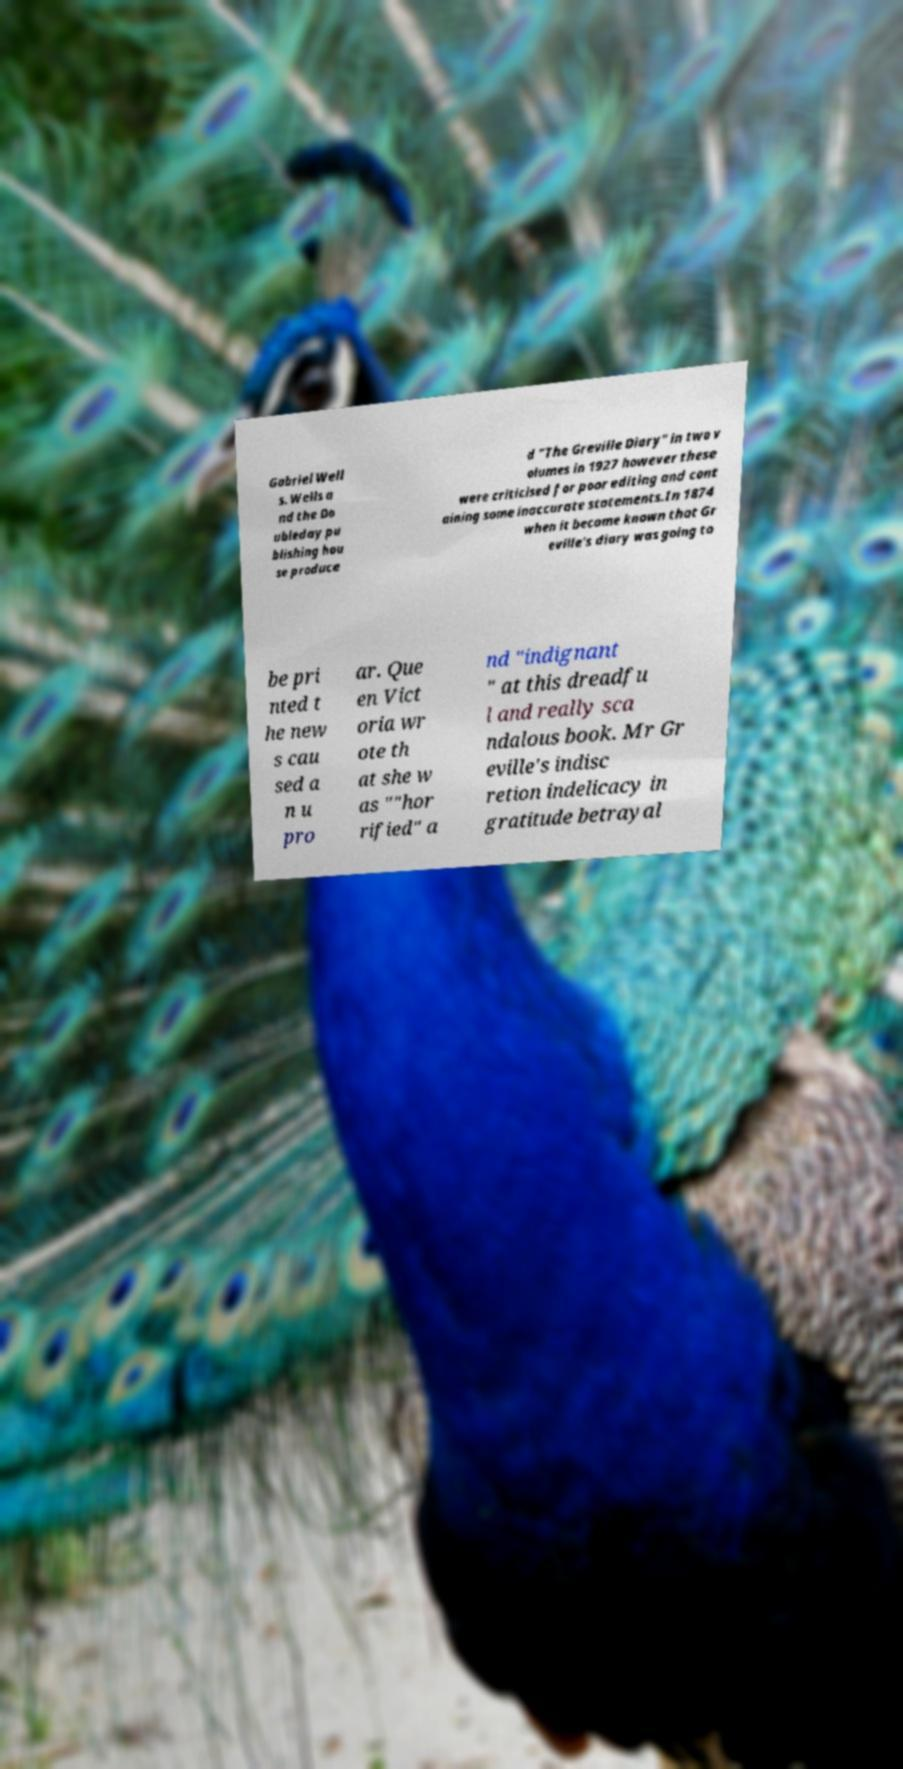Could you assist in decoding the text presented in this image and type it out clearly? Gabriel Well s. Wells a nd the Do ubleday pu blishing hou se produce d "The Greville Diary" in two v olumes in 1927 however these were criticised for poor editing and cont aining some inaccurate statements.In 1874 when it became known that Gr eville's diary was going to be pri nted t he new s cau sed a n u pro ar. Que en Vict oria wr ote th at she w as ""hor rified" a nd "indignant " at this dreadfu l and really sca ndalous book. Mr Gr eville's indisc retion indelicacy in gratitude betrayal 